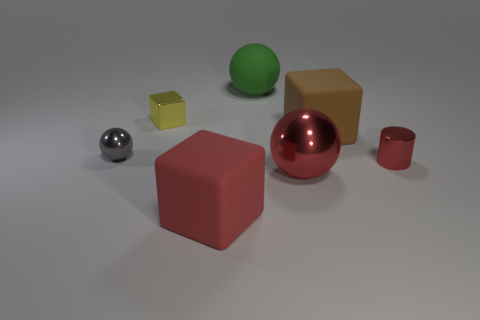Add 1 large brown cubes. How many objects exist? 8 Subtract all shiny spheres. How many spheres are left? 1 Subtract all yellow blocks. How many blocks are left? 2 Subtract all spheres. How many objects are left? 4 Subtract 1 spheres. How many spheres are left? 2 Subtract 0 green cylinders. How many objects are left? 7 Subtract all brown cubes. Subtract all blue cylinders. How many cubes are left? 2 Subtract all yellow spheres. How many gray blocks are left? 0 Subtract all gray spheres. Subtract all large matte spheres. How many objects are left? 5 Add 6 red objects. How many red objects are left? 9 